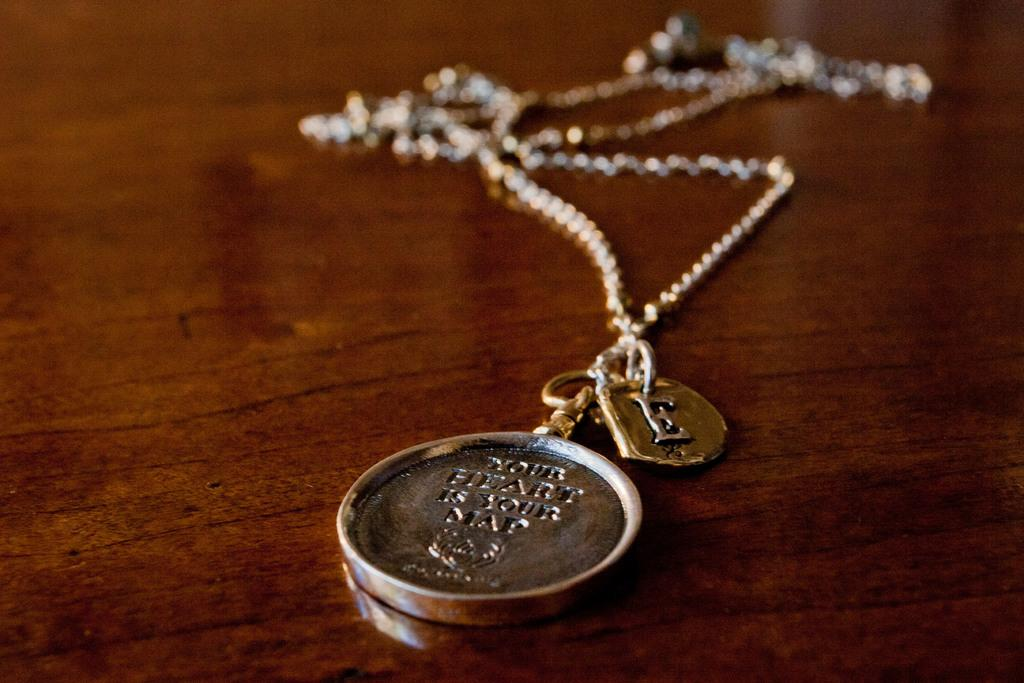Provide a one-sentence caption for the provided image. A necklace that has the words your heart is your map engraved on it. 